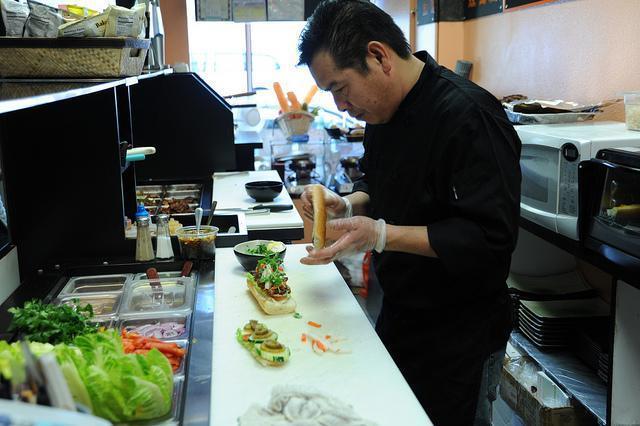Is the given caption "The oven is at the back of the person." fitting for the image?
Answer yes or no. Yes. 